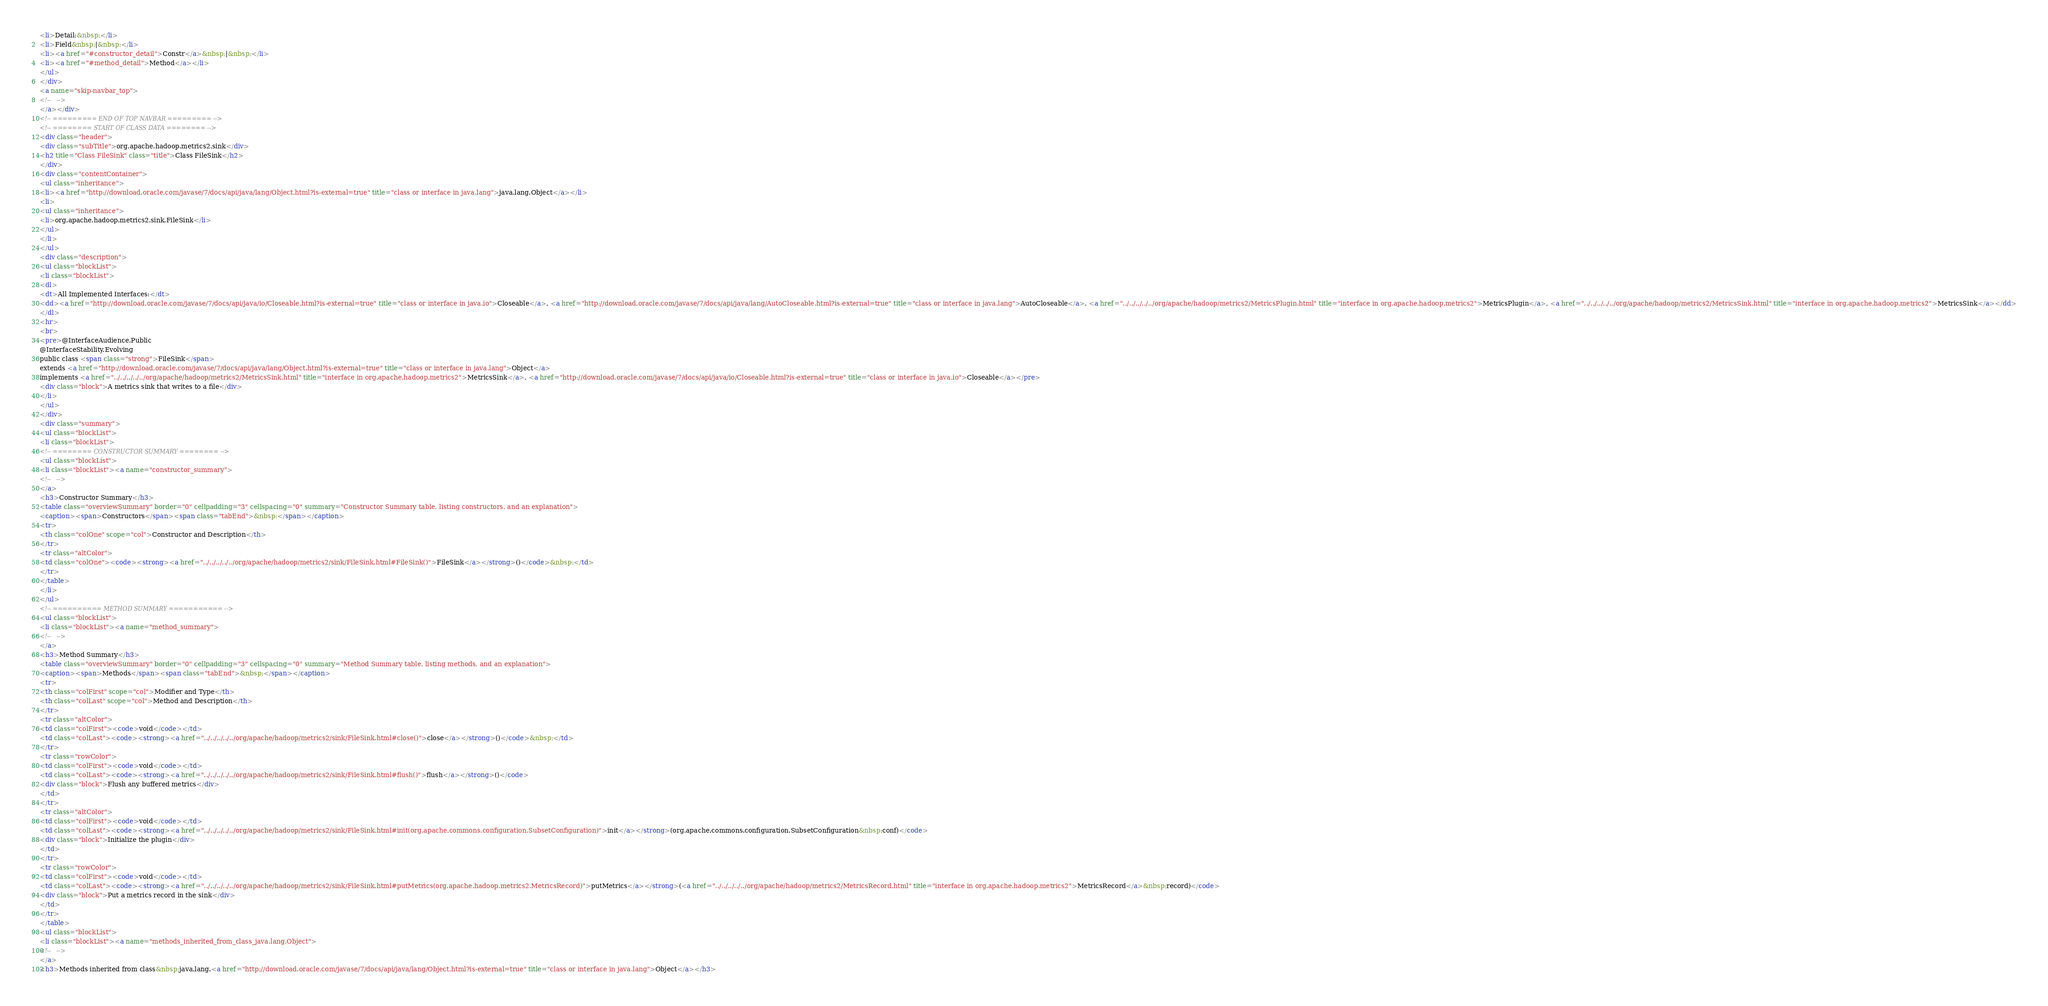<code> <loc_0><loc_0><loc_500><loc_500><_HTML_><li>Detail:&nbsp;</li>
<li>Field&nbsp;|&nbsp;</li>
<li><a href="#constructor_detail">Constr</a>&nbsp;|&nbsp;</li>
<li><a href="#method_detail">Method</a></li>
</ul>
</div>
<a name="skip-navbar_top">
<!--   -->
</a></div>
<!-- ========= END OF TOP NAVBAR ========= -->
<!-- ======== START OF CLASS DATA ======== -->
<div class="header">
<div class="subTitle">org.apache.hadoop.metrics2.sink</div>
<h2 title="Class FileSink" class="title">Class FileSink</h2>
</div>
<div class="contentContainer">
<ul class="inheritance">
<li><a href="http://download.oracle.com/javase/7/docs/api/java/lang/Object.html?is-external=true" title="class or interface in java.lang">java.lang.Object</a></li>
<li>
<ul class="inheritance">
<li>org.apache.hadoop.metrics2.sink.FileSink</li>
</ul>
</li>
</ul>
<div class="description">
<ul class="blockList">
<li class="blockList">
<dl>
<dt>All Implemented Interfaces:</dt>
<dd><a href="http://download.oracle.com/javase/7/docs/api/java/io/Closeable.html?is-external=true" title="class or interface in java.io">Closeable</a>, <a href="http://download.oracle.com/javase/7/docs/api/java/lang/AutoCloseable.html?is-external=true" title="class or interface in java.lang">AutoCloseable</a>, <a href="../../../../../org/apache/hadoop/metrics2/MetricsPlugin.html" title="interface in org.apache.hadoop.metrics2">MetricsPlugin</a>, <a href="../../../../../org/apache/hadoop/metrics2/MetricsSink.html" title="interface in org.apache.hadoop.metrics2">MetricsSink</a></dd>
</dl>
<hr>
<br>
<pre>@InterfaceAudience.Public
@InterfaceStability.Evolving
public class <span class="strong">FileSink</span>
extends <a href="http://download.oracle.com/javase/7/docs/api/java/lang/Object.html?is-external=true" title="class or interface in java.lang">Object</a>
implements <a href="../../../../../org/apache/hadoop/metrics2/MetricsSink.html" title="interface in org.apache.hadoop.metrics2">MetricsSink</a>, <a href="http://download.oracle.com/javase/7/docs/api/java/io/Closeable.html?is-external=true" title="class or interface in java.io">Closeable</a></pre>
<div class="block">A metrics sink that writes to a file</div>
</li>
</ul>
</div>
<div class="summary">
<ul class="blockList">
<li class="blockList">
<!-- ======== CONSTRUCTOR SUMMARY ======== -->
<ul class="blockList">
<li class="blockList"><a name="constructor_summary">
<!--   -->
</a>
<h3>Constructor Summary</h3>
<table class="overviewSummary" border="0" cellpadding="3" cellspacing="0" summary="Constructor Summary table, listing constructors, and an explanation">
<caption><span>Constructors</span><span class="tabEnd">&nbsp;</span></caption>
<tr>
<th class="colOne" scope="col">Constructor and Description</th>
</tr>
<tr class="altColor">
<td class="colOne"><code><strong><a href="../../../../../org/apache/hadoop/metrics2/sink/FileSink.html#FileSink()">FileSink</a></strong>()</code>&nbsp;</td>
</tr>
</table>
</li>
</ul>
<!-- ========== METHOD SUMMARY =========== -->
<ul class="blockList">
<li class="blockList"><a name="method_summary">
<!--   -->
</a>
<h3>Method Summary</h3>
<table class="overviewSummary" border="0" cellpadding="3" cellspacing="0" summary="Method Summary table, listing methods, and an explanation">
<caption><span>Methods</span><span class="tabEnd">&nbsp;</span></caption>
<tr>
<th class="colFirst" scope="col">Modifier and Type</th>
<th class="colLast" scope="col">Method and Description</th>
</tr>
<tr class="altColor">
<td class="colFirst"><code>void</code></td>
<td class="colLast"><code><strong><a href="../../../../../org/apache/hadoop/metrics2/sink/FileSink.html#close()">close</a></strong>()</code>&nbsp;</td>
</tr>
<tr class="rowColor">
<td class="colFirst"><code>void</code></td>
<td class="colLast"><code><strong><a href="../../../../../org/apache/hadoop/metrics2/sink/FileSink.html#flush()">flush</a></strong>()</code>
<div class="block">Flush any buffered metrics</div>
</td>
</tr>
<tr class="altColor">
<td class="colFirst"><code>void</code></td>
<td class="colLast"><code><strong><a href="../../../../../org/apache/hadoop/metrics2/sink/FileSink.html#init(org.apache.commons.configuration.SubsetConfiguration)">init</a></strong>(org.apache.commons.configuration.SubsetConfiguration&nbsp;conf)</code>
<div class="block">Initialize the plugin</div>
</td>
</tr>
<tr class="rowColor">
<td class="colFirst"><code>void</code></td>
<td class="colLast"><code><strong><a href="../../../../../org/apache/hadoop/metrics2/sink/FileSink.html#putMetrics(org.apache.hadoop.metrics2.MetricsRecord)">putMetrics</a></strong>(<a href="../../../../../org/apache/hadoop/metrics2/MetricsRecord.html" title="interface in org.apache.hadoop.metrics2">MetricsRecord</a>&nbsp;record)</code>
<div class="block">Put a metrics record in the sink</div>
</td>
</tr>
</table>
<ul class="blockList">
<li class="blockList"><a name="methods_inherited_from_class_java.lang.Object">
<!--   -->
</a>
<h3>Methods inherited from class&nbsp;java.lang.<a href="http://download.oracle.com/javase/7/docs/api/java/lang/Object.html?is-external=true" title="class or interface in java.lang">Object</a></h3></code> 